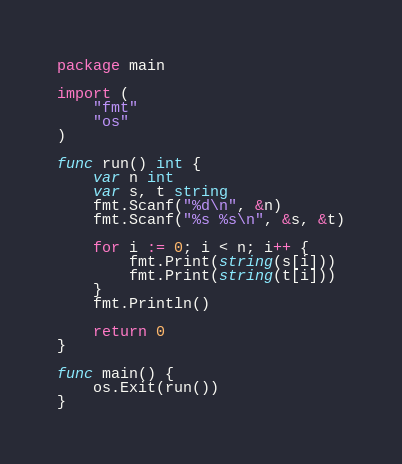Convert code to text. <code><loc_0><loc_0><loc_500><loc_500><_Go_>package main

import (
	"fmt"
	"os"
)

func run() int {
	var n int
	var s, t string
	fmt.Scanf("%d\n", &n)
	fmt.Scanf("%s %s\n", &s, &t)

	for i := 0; i < n; i++ {
		fmt.Print(string(s[i]))
		fmt.Print(string(t[i]))
	}
	fmt.Println()

	return 0
}

func main() {
	os.Exit(run())
}
</code> 